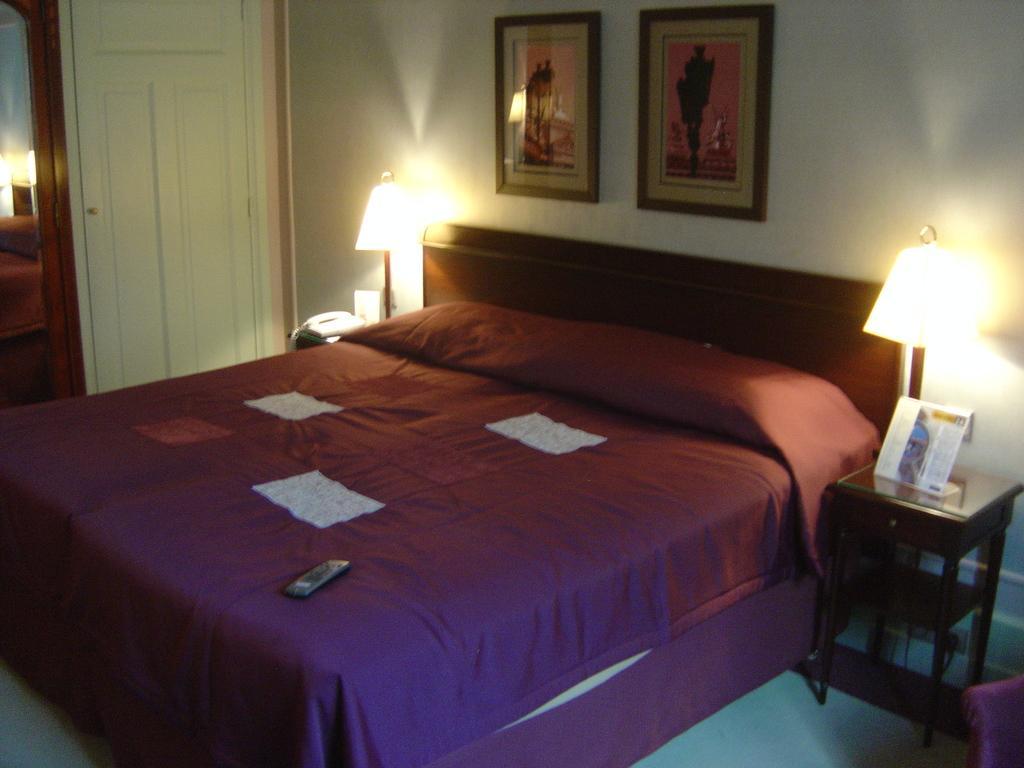How would you summarize this image in a sentence or two? In this image I can see a bed which is brown and white in color and I can see a remote control which is black in color on the bed. I can see two lamps, the wall, two photo frames attached to the wall, a table with an object on it, the white colored door and a mirror to the left side of the image. 